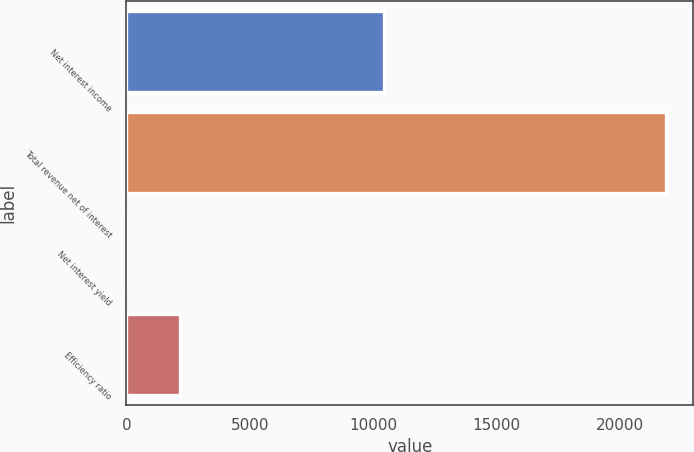Convert chart. <chart><loc_0><loc_0><loc_500><loc_500><bar_chart><fcel>Net interest income<fcel>Total revenue net of interest<fcel>Net interest yield<fcel>Efficiency ratio<nl><fcel>10429<fcel>21863<fcel>2.23<fcel>2188.31<nl></chart> 